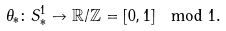<formula> <loc_0><loc_0><loc_500><loc_500>\theta _ { * } \colon S ^ { 1 } _ { * } \to { \mathbb { R } } / { \mathbb { Z } } = [ 0 , 1 ] \mod 1 .</formula> 